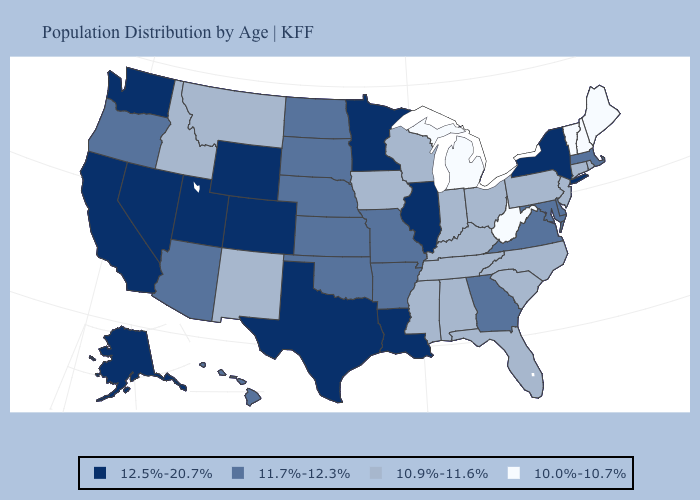Which states hav the highest value in the West?
Answer briefly. Alaska, California, Colorado, Nevada, Utah, Washington, Wyoming. Does the map have missing data?
Write a very short answer. No. Name the states that have a value in the range 11.7%-12.3%?
Short answer required. Arizona, Arkansas, Delaware, Georgia, Hawaii, Kansas, Maryland, Massachusetts, Missouri, Nebraska, North Dakota, Oklahoma, Oregon, South Dakota, Virginia. Name the states that have a value in the range 12.5%-20.7%?
Give a very brief answer. Alaska, California, Colorado, Illinois, Louisiana, Minnesota, Nevada, New York, Texas, Utah, Washington, Wyoming. What is the value of Oklahoma?
Keep it brief. 11.7%-12.3%. What is the value of South Dakota?
Be succinct. 11.7%-12.3%. What is the highest value in states that border Pennsylvania?
Give a very brief answer. 12.5%-20.7%. Does Virginia have the same value as Georgia?
Answer briefly. Yes. Does Minnesota have the highest value in the MidWest?
Short answer required. Yes. Does Illinois have a higher value than New Hampshire?
Keep it brief. Yes. What is the value of Oklahoma?
Answer briefly. 11.7%-12.3%. Among the states that border Oregon , which have the highest value?
Keep it brief. California, Nevada, Washington. What is the value of Oklahoma?
Short answer required. 11.7%-12.3%. Among the states that border Wyoming , does Montana have the lowest value?
Concise answer only. Yes. Does West Virginia have the lowest value in the USA?
Keep it brief. Yes. 